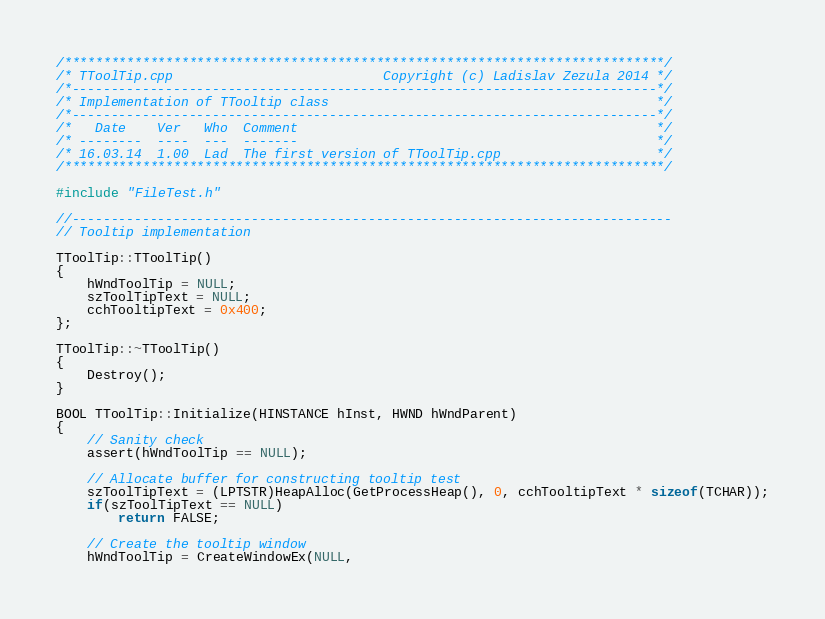Convert code to text. <code><loc_0><loc_0><loc_500><loc_500><_C++_>/*****************************************************************************/
/* TToolTip.cpp                           Copyright (c) Ladislav Zezula 2014 */
/*---------------------------------------------------------------------------*/
/* Implementation of TTooltip class                                          */
/*---------------------------------------------------------------------------*/
/*   Date    Ver   Who  Comment                                              */
/* --------  ----  ---  -------                                              */
/* 16.03.14  1.00  Lad  The first version of TToolTip.cpp                    */
/*****************************************************************************/

#include "FileTest.h"

//-----------------------------------------------------------------------------
// Tooltip implementation

TToolTip::TToolTip()
{
    hWndToolTip = NULL;
    szToolTipText = NULL;
    cchTooltipText = 0x400;
};

TToolTip::~TToolTip()
{
    Destroy();
}

BOOL TToolTip::Initialize(HINSTANCE hInst, HWND hWndParent)
{
    // Sanity check
    assert(hWndToolTip == NULL);

    // Allocate buffer for constructing tooltip test
    szToolTipText = (LPTSTR)HeapAlloc(GetProcessHeap(), 0, cchTooltipText * sizeof(TCHAR));
    if(szToolTipText == NULL)
        return FALSE;

    // Create the tooltip window
    hWndToolTip = CreateWindowEx(NULL,</code> 